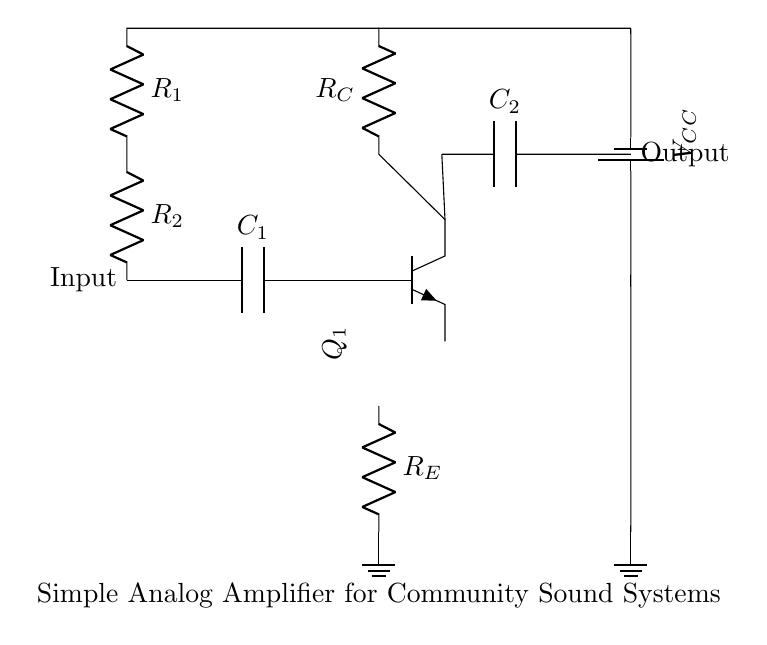What type of transistor is used in this circuit? The circuit shows an npn transistor, which is indicated by the symbol in the diagram.
Answer: npn What is the value of the coupling capacitor at the input? The capacitor labeled C1 is used for coupling at the input, as indicated by the label next to it.
Answer: C1 How many resistors are present in the output section? The output section does not contain any resistors; the components are a capacitor and the output connection.
Answer: 0 What is the purpose of the resistor labeled R_E? R_E acts as an emitter resistor, providing stability and improving linearity in the amplifier circuit.
Answer: Emitter stabilization What is the voltage supply for the circuit? The circuit has a voltage supply indicated by the battery symbol, labeled as V_CC.
Answer: V_CC How does the value of R_C affect the gain of the amplifier? The resistor R_C affects the gain by providing necessary voltage drop across the collector; higher values can increase gain but may limit output swing.
Answer: Higher gain 